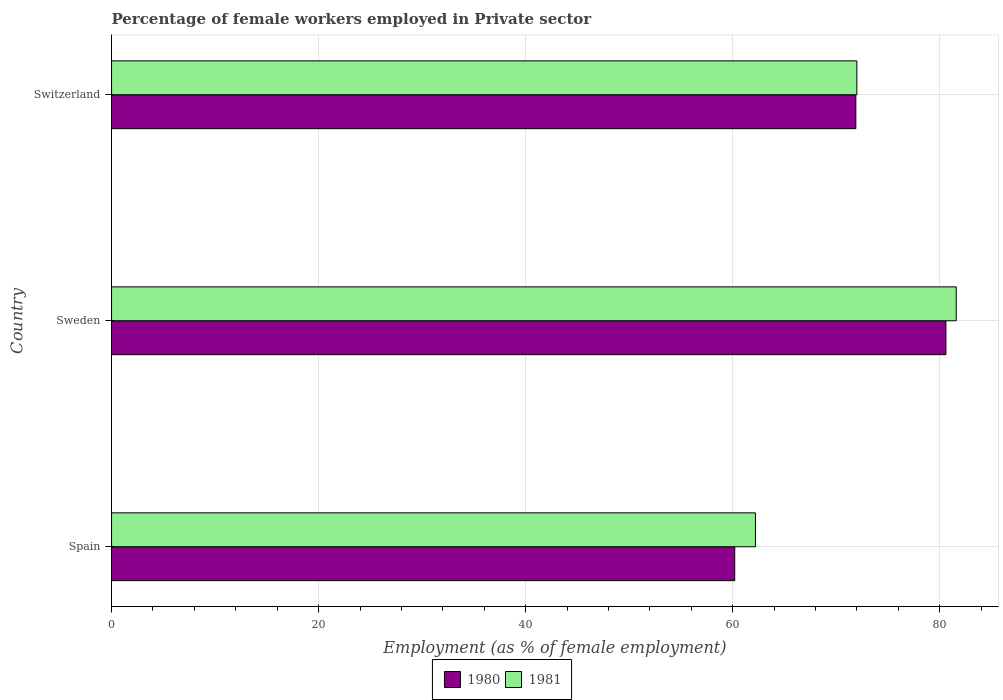How many different coloured bars are there?
Offer a terse response. 2. How many groups of bars are there?
Keep it short and to the point. 3. Are the number of bars on each tick of the Y-axis equal?
Your response must be concise. Yes. How many bars are there on the 3rd tick from the bottom?
Offer a very short reply. 2. What is the percentage of females employed in Private sector in 1981 in Switzerland?
Your answer should be compact. 72. Across all countries, what is the maximum percentage of females employed in Private sector in 1980?
Provide a short and direct response. 80.6. Across all countries, what is the minimum percentage of females employed in Private sector in 1980?
Offer a terse response. 60.2. In which country was the percentage of females employed in Private sector in 1980 minimum?
Your response must be concise. Spain. What is the total percentage of females employed in Private sector in 1980 in the graph?
Keep it short and to the point. 212.7. What is the difference between the percentage of females employed in Private sector in 1980 in Sweden and that in Switzerland?
Keep it short and to the point. 8.7. What is the difference between the percentage of females employed in Private sector in 1980 in Switzerland and the percentage of females employed in Private sector in 1981 in Sweden?
Provide a short and direct response. -9.7. What is the average percentage of females employed in Private sector in 1981 per country?
Keep it short and to the point. 71.93. In how many countries, is the percentage of females employed in Private sector in 1981 greater than 12 %?
Provide a short and direct response. 3. What is the ratio of the percentage of females employed in Private sector in 1980 in Sweden to that in Switzerland?
Give a very brief answer. 1.12. Is the percentage of females employed in Private sector in 1981 in Spain less than that in Switzerland?
Your response must be concise. Yes. Is the difference between the percentage of females employed in Private sector in 1980 in Spain and Switzerland greater than the difference between the percentage of females employed in Private sector in 1981 in Spain and Switzerland?
Offer a terse response. No. What is the difference between the highest and the second highest percentage of females employed in Private sector in 1981?
Your answer should be compact. 9.6. What is the difference between the highest and the lowest percentage of females employed in Private sector in 1980?
Your answer should be compact. 20.4. In how many countries, is the percentage of females employed in Private sector in 1980 greater than the average percentage of females employed in Private sector in 1980 taken over all countries?
Your response must be concise. 2. What does the 1st bar from the top in Spain represents?
Ensure brevity in your answer.  1981. How many bars are there?
Provide a succinct answer. 6. Does the graph contain any zero values?
Offer a very short reply. No. Where does the legend appear in the graph?
Offer a very short reply. Bottom center. How many legend labels are there?
Provide a succinct answer. 2. What is the title of the graph?
Ensure brevity in your answer.  Percentage of female workers employed in Private sector. Does "2013" appear as one of the legend labels in the graph?
Offer a very short reply. No. What is the label or title of the X-axis?
Provide a succinct answer. Employment (as % of female employment). What is the label or title of the Y-axis?
Your answer should be very brief. Country. What is the Employment (as % of female employment) of 1980 in Spain?
Provide a short and direct response. 60.2. What is the Employment (as % of female employment) of 1981 in Spain?
Provide a short and direct response. 62.2. What is the Employment (as % of female employment) of 1980 in Sweden?
Ensure brevity in your answer.  80.6. What is the Employment (as % of female employment) of 1981 in Sweden?
Your answer should be compact. 81.6. What is the Employment (as % of female employment) of 1980 in Switzerland?
Keep it short and to the point. 71.9. Across all countries, what is the maximum Employment (as % of female employment) in 1980?
Keep it short and to the point. 80.6. Across all countries, what is the maximum Employment (as % of female employment) of 1981?
Provide a short and direct response. 81.6. Across all countries, what is the minimum Employment (as % of female employment) in 1980?
Provide a short and direct response. 60.2. Across all countries, what is the minimum Employment (as % of female employment) in 1981?
Keep it short and to the point. 62.2. What is the total Employment (as % of female employment) in 1980 in the graph?
Provide a short and direct response. 212.7. What is the total Employment (as % of female employment) in 1981 in the graph?
Your answer should be very brief. 215.8. What is the difference between the Employment (as % of female employment) in 1980 in Spain and that in Sweden?
Keep it short and to the point. -20.4. What is the difference between the Employment (as % of female employment) in 1981 in Spain and that in Sweden?
Give a very brief answer. -19.4. What is the difference between the Employment (as % of female employment) of 1980 in Sweden and that in Switzerland?
Give a very brief answer. 8.7. What is the difference between the Employment (as % of female employment) in 1981 in Sweden and that in Switzerland?
Ensure brevity in your answer.  9.6. What is the difference between the Employment (as % of female employment) in 1980 in Spain and the Employment (as % of female employment) in 1981 in Sweden?
Offer a very short reply. -21.4. What is the difference between the Employment (as % of female employment) of 1980 in Spain and the Employment (as % of female employment) of 1981 in Switzerland?
Provide a short and direct response. -11.8. What is the difference between the Employment (as % of female employment) in 1980 in Sweden and the Employment (as % of female employment) in 1981 in Switzerland?
Ensure brevity in your answer.  8.6. What is the average Employment (as % of female employment) of 1980 per country?
Offer a very short reply. 70.9. What is the average Employment (as % of female employment) in 1981 per country?
Keep it short and to the point. 71.93. What is the difference between the Employment (as % of female employment) of 1980 and Employment (as % of female employment) of 1981 in Spain?
Your response must be concise. -2. What is the difference between the Employment (as % of female employment) of 1980 and Employment (as % of female employment) of 1981 in Sweden?
Offer a very short reply. -1. What is the ratio of the Employment (as % of female employment) of 1980 in Spain to that in Sweden?
Give a very brief answer. 0.75. What is the ratio of the Employment (as % of female employment) of 1981 in Spain to that in Sweden?
Keep it short and to the point. 0.76. What is the ratio of the Employment (as % of female employment) of 1980 in Spain to that in Switzerland?
Make the answer very short. 0.84. What is the ratio of the Employment (as % of female employment) of 1981 in Spain to that in Switzerland?
Your answer should be very brief. 0.86. What is the ratio of the Employment (as % of female employment) in 1980 in Sweden to that in Switzerland?
Ensure brevity in your answer.  1.12. What is the ratio of the Employment (as % of female employment) of 1981 in Sweden to that in Switzerland?
Give a very brief answer. 1.13. What is the difference between the highest and the second highest Employment (as % of female employment) in 1980?
Your answer should be compact. 8.7. What is the difference between the highest and the second highest Employment (as % of female employment) in 1981?
Provide a succinct answer. 9.6. What is the difference between the highest and the lowest Employment (as % of female employment) of 1980?
Make the answer very short. 20.4. What is the difference between the highest and the lowest Employment (as % of female employment) in 1981?
Provide a succinct answer. 19.4. 